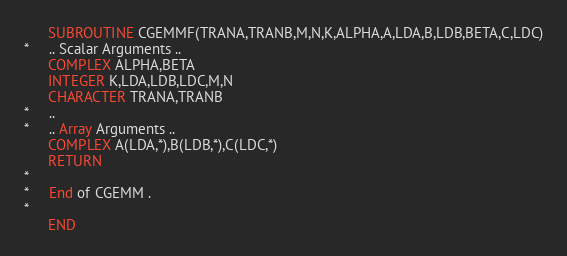<code> <loc_0><loc_0><loc_500><loc_500><_FORTRAN_>      SUBROUTINE CGEMMF(TRANA,TRANB,M,N,K,ALPHA,A,LDA,B,LDB,BETA,C,LDC)
*     .. Scalar Arguments ..
      COMPLEX ALPHA,BETA
      INTEGER K,LDA,LDB,LDC,M,N
      CHARACTER TRANA,TRANB
*     ..
*     .. Array Arguments ..
      COMPLEX A(LDA,*),B(LDB,*),C(LDC,*)
      RETURN
*
*     End of CGEMM .
*
      END
</code> 